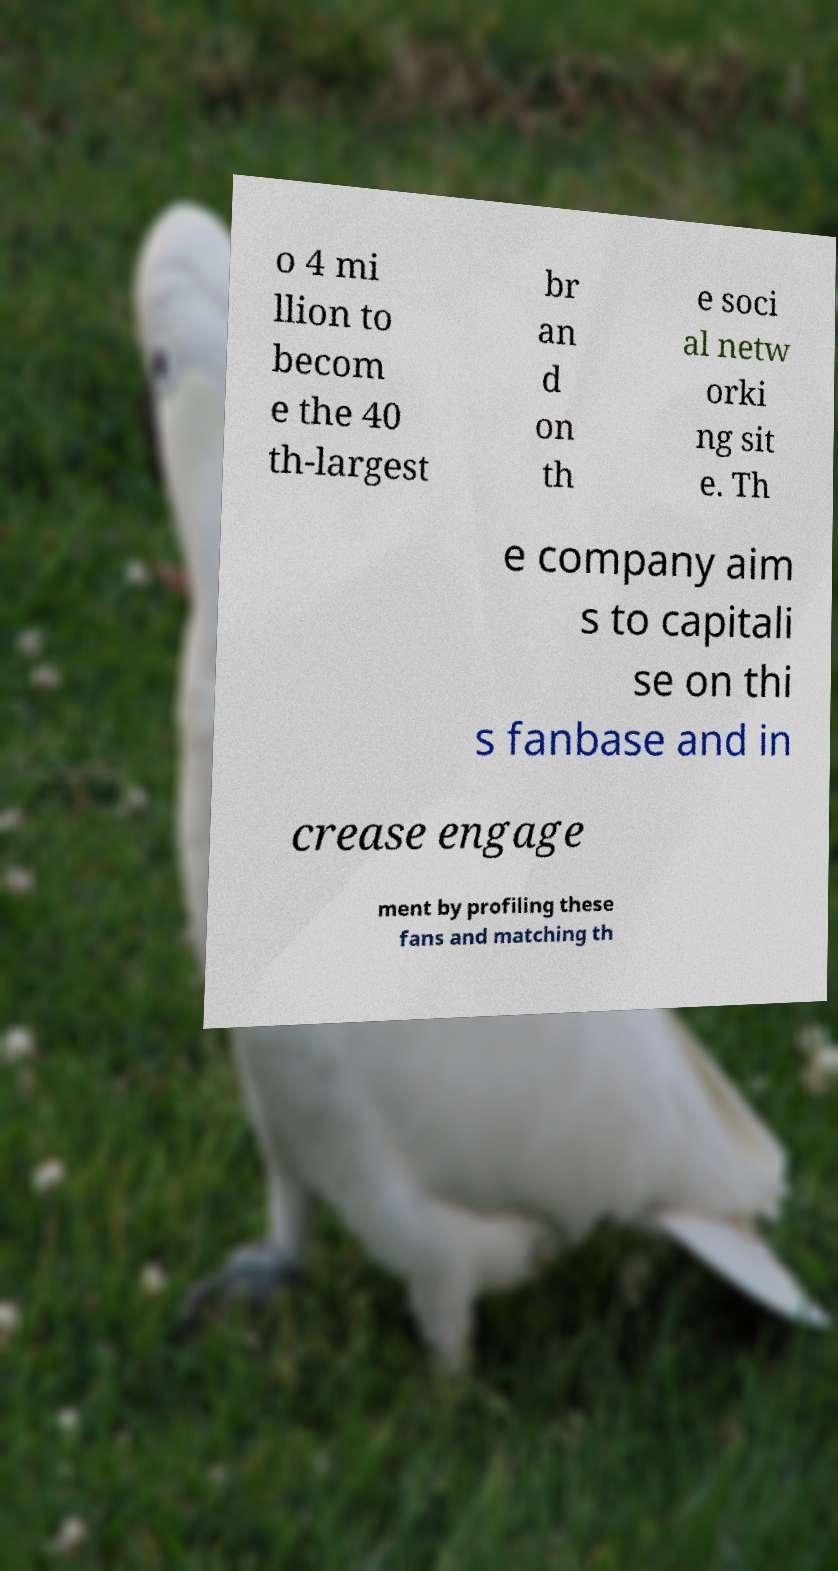Could you extract and type out the text from this image? o 4 mi llion to becom e the 40 th-largest br an d on th e soci al netw orki ng sit e. Th e company aim s to capitali se on thi s fanbase and in crease engage ment by profiling these fans and matching th 